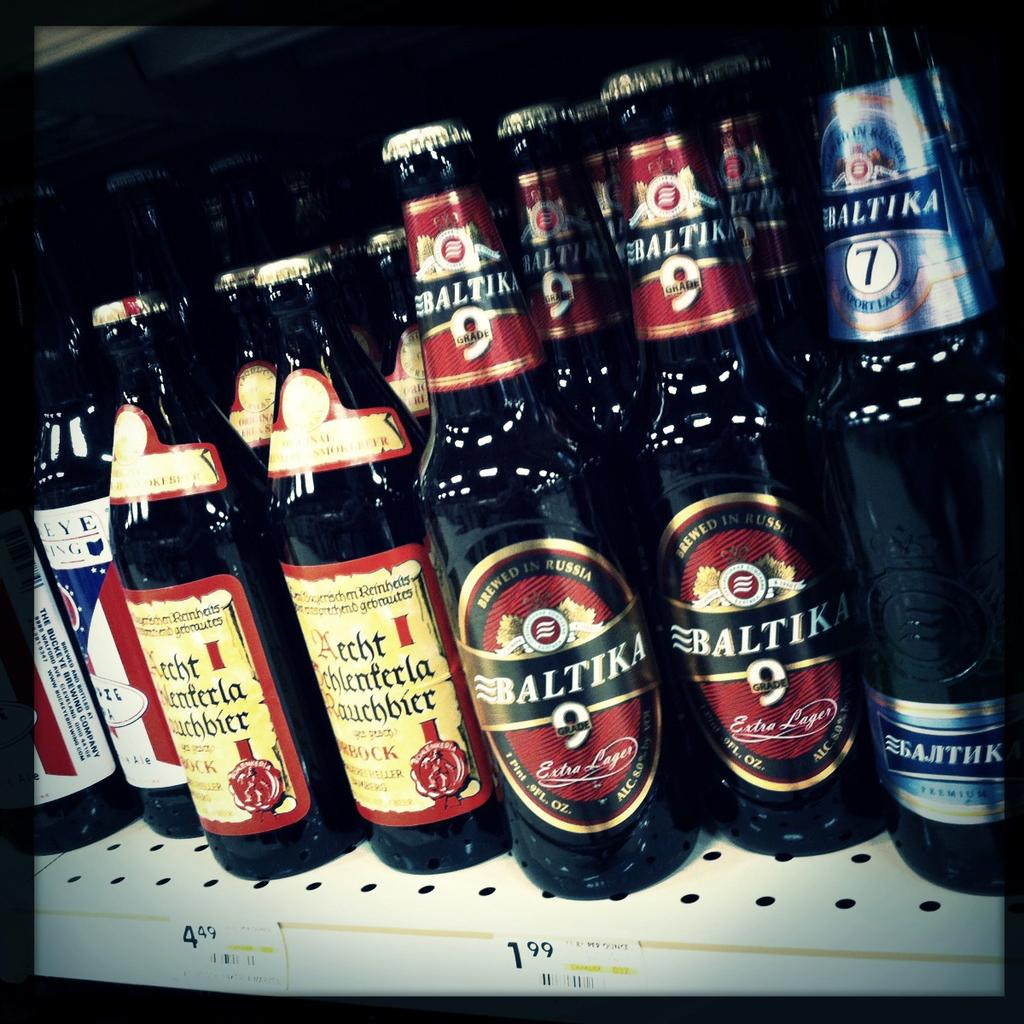<image>
Summarize the visual content of the image. Baltika bottles of beer are on a shelf next to other bottles. 